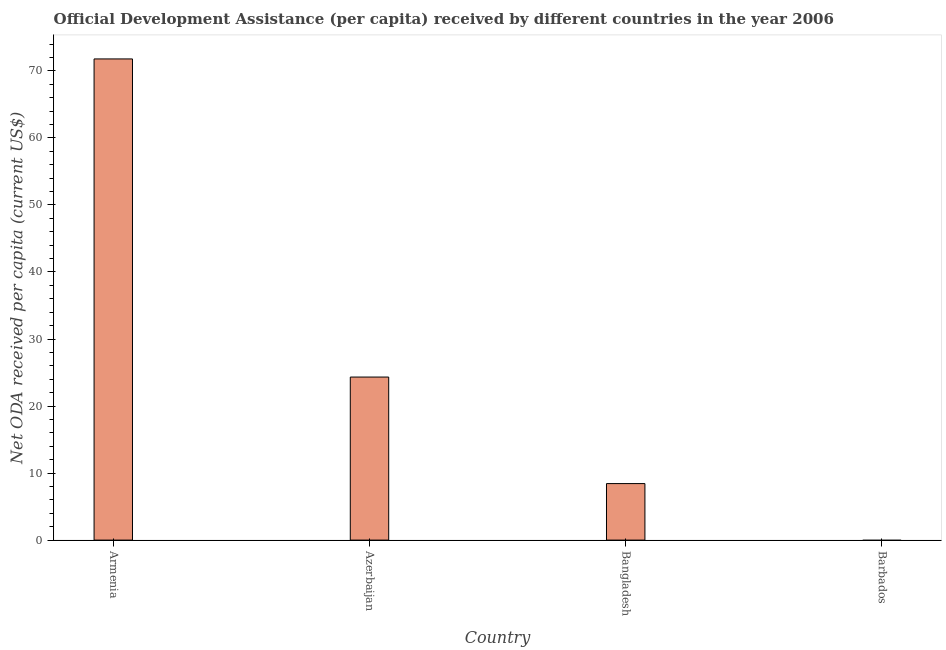Does the graph contain any zero values?
Make the answer very short. Yes. What is the title of the graph?
Ensure brevity in your answer.  Official Development Assistance (per capita) received by different countries in the year 2006. What is the label or title of the Y-axis?
Provide a succinct answer. Net ODA received per capita (current US$). What is the net oda received per capita in Armenia?
Your response must be concise. 71.78. Across all countries, what is the maximum net oda received per capita?
Keep it short and to the point. 71.78. In which country was the net oda received per capita maximum?
Provide a succinct answer. Armenia. What is the sum of the net oda received per capita?
Provide a short and direct response. 104.54. What is the difference between the net oda received per capita in Armenia and Bangladesh?
Your response must be concise. 63.35. What is the average net oda received per capita per country?
Keep it short and to the point. 26.14. What is the median net oda received per capita?
Keep it short and to the point. 16.38. In how many countries, is the net oda received per capita greater than 46 US$?
Your response must be concise. 1. What is the ratio of the net oda received per capita in Armenia to that in Azerbaijan?
Provide a succinct answer. 2.95. Is the net oda received per capita in Azerbaijan less than that in Bangladesh?
Offer a terse response. No. Is the difference between the net oda received per capita in Armenia and Bangladesh greater than the difference between any two countries?
Give a very brief answer. No. What is the difference between the highest and the second highest net oda received per capita?
Keep it short and to the point. 47.46. What is the difference between the highest and the lowest net oda received per capita?
Your response must be concise. 71.78. How many bars are there?
Ensure brevity in your answer.  3. What is the difference between two consecutive major ticks on the Y-axis?
Keep it short and to the point. 10. Are the values on the major ticks of Y-axis written in scientific E-notation?
Provide a succinct answer. No. What is the Net ODA received per capita (current US$) of Armenia?
Offer a very short reply. 71.78. What is the Net ODA received per capita (current US$) of Azerbaijan?
Provide a succinct answer. 24.33. What is the Net ODA received per capita (current US$) of Bangladesh?
Give a very brief answer. 8.43. What is the Net ODA received per capita (current US$) in Barbados?
Keep it short and to the point. 0. What is the difference between the Net ODA received per capita (current US$) in Armenia and Azerbaijan?
Provide a succinct answer. 47.46. What is the difference between the Net ODA received per capita (current US$) in Armenia and Bangladesh?
Make the answer very short. 63.35. What is the difference between the Net ODA received per capita (current US$) in Azerbaijan and Bangladesh?
Make the answer very short. 15.89. What is the ratio of the Net ODA received per capita (current US$) in Armenia to that in Azerbaijan?
Your answer should be very brief. 2.95. What is the ratio of the Net ODA received per capita (current US$) in Armenia to that in Bangladesh?
Offer a very short reply. 8.51. What is the ratio of the Net ODA received per capita (current US$) in Azerbaijan to that in Bangladesh?
Keep it short and to the point. 2.88. 